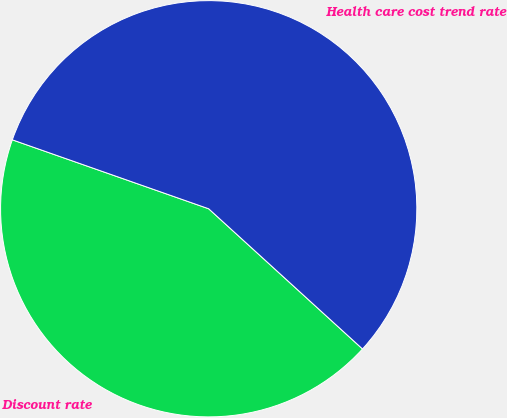Convert chart to OTSL. <chart><loc_0><loc_0><loc_500><loc_500><pie_chart><fcel>Discount rate<fcel>Health care cost trend rate<nl><fcel>43.61%<fcel>56.39%<nl></chart> 